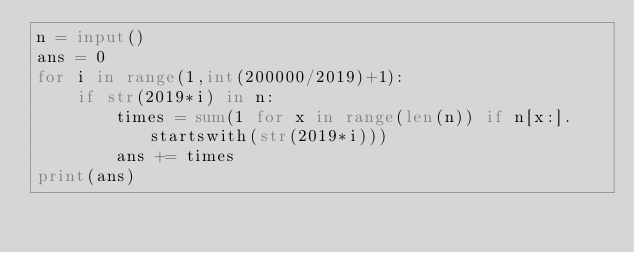Convert code to text. <code><loc_0><loc_0><loc_500><loc_500><_Python_>n = input()
ans = 0
for i in range(1,int(200000/2019)+1):
    if str(2019*i) in n:
        times = sum(1 for x in range(len(n)) if n[x:].startswith(str(2019*i)))
        ans += times
print(ans)
</code> 